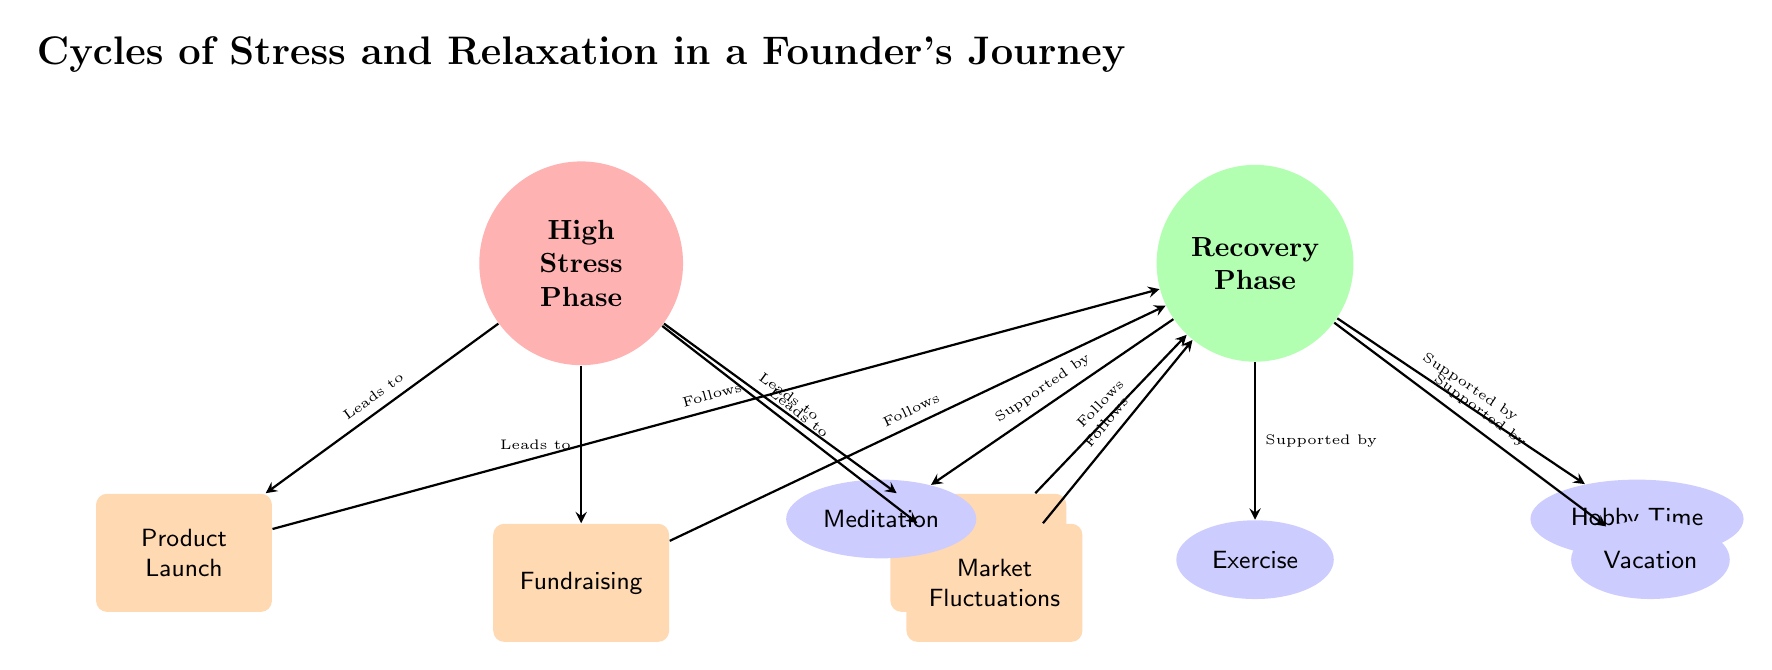What is the first phase shown in the diagram? The diagram starts with the "High Stress Phase" at the top left. This phase is colored in red and labeled accordingly.
Answer: High Stress Phase How many events are linked to the High Stress Phase? There are four events linked to the "High Stress Phase": Product Launch, Fundraising, Team Issues, and Market Fluctuations, making a total of four.
Answer: 4 Which phase comes after the events linked to High Stress? Each event linked to "High Stress Phase" leads to the "Recovery Phase," which directly follows them. This is clearly represented in the diagram.
Answer: Recovery Phase What activities support the Recovery Phase? The Recovery Phase is supported by four activities: Meditation, Exercise, Hobby Time, and Vacation, as indicated by their connections in the diagram.
Answer: Meditation, Exercise, Hobby Time, Vacation What color represents the High Stress Phase? The High Stress Phase is represented in a shade of red, specifically noted in the diagram.
Answer: Red Which event leads to Recovery from Fundraising? In the diagram, Fundraising leads to the Recovery Phase, as depicted by the arrow connecting them.
Answer: Recovery Phase In total, how many phases are illustrated in the diagram? The diagram illustrates two distinct phases: High Stress Phase and Recovery Phase.
Answer: 2 What type of diagram is this? This representation is an Astronomy Diagram, specifically visualizing the cycles of stress and relaxation in a founder's journey.
Answer: Astronomy Diagram Which activity is directly below the Recovery Phase in the diagram? The activity directly below the Recovery Phase is Meditation, as per the layout of the nodes.
Answer: Meditation 